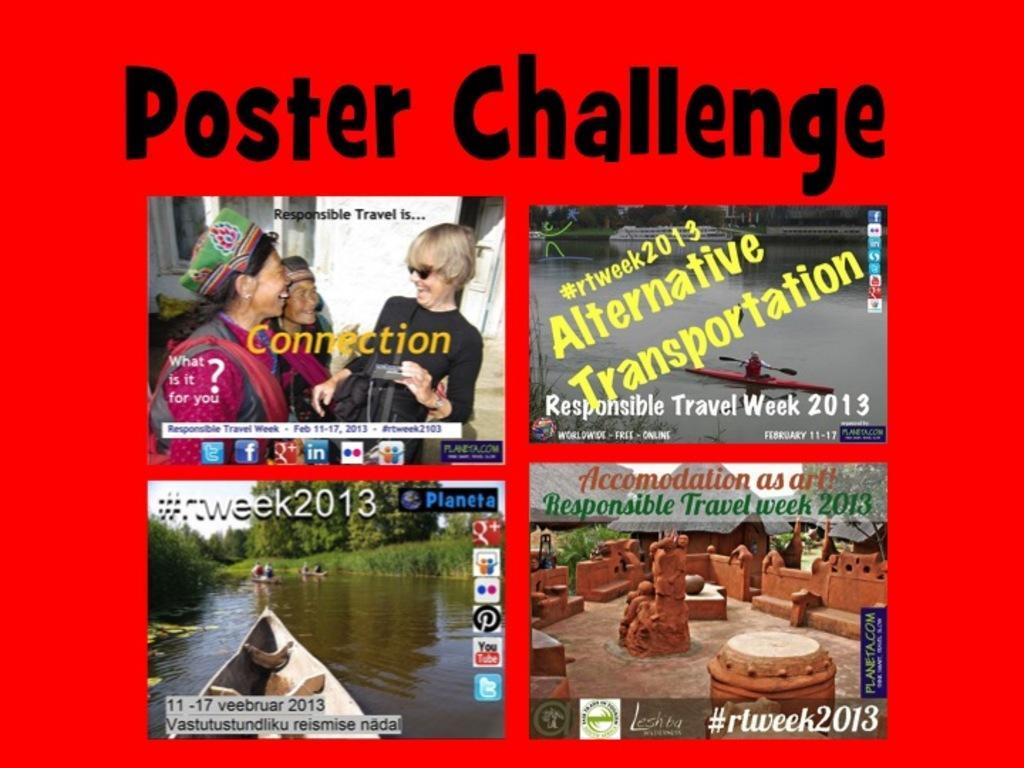How would you summarize this image in a sentence or two? This image consists of a poster. On this poster, I can see the text and four pictures. In the bottom right-hand picture there are few wooden objects and houses. In the bottom left-hand image, I can see the boats on the water and many trees. In the top left-hand picture, I can see few people smiling. In the top right-hand image there is a boat on the water. 